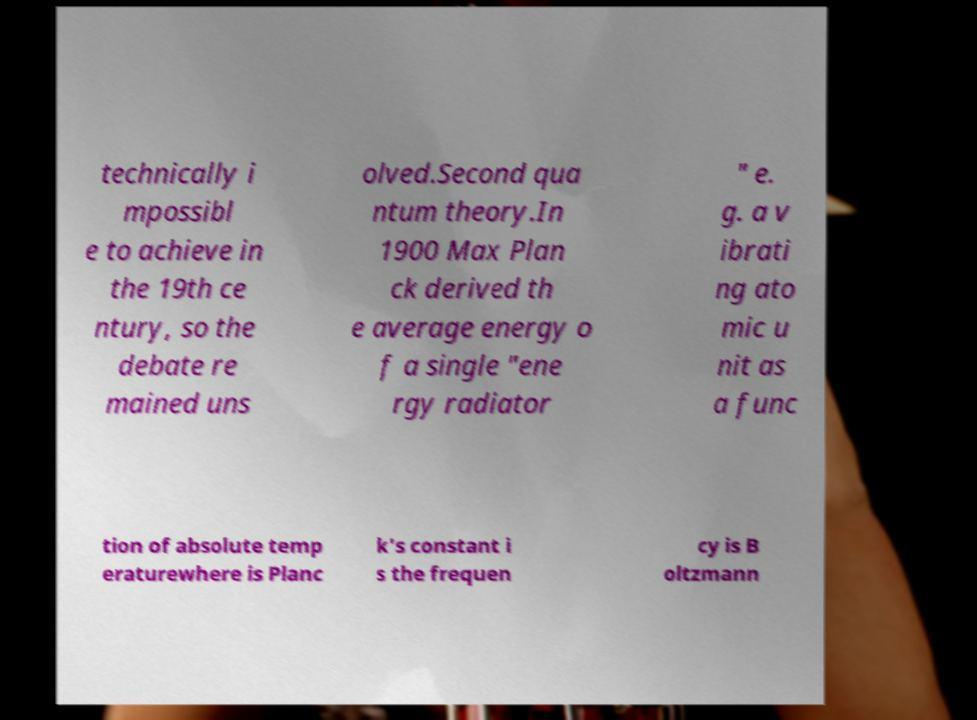I need the written content from this picture converted into text. Can you do that? technically i mpossibl e to achieve in the 19th ce ntury, so the debate re mained uns olved.Second qua ntum theory.In 1900 Max Plan ck derived th e average energy o f a single "ene rgy radiator " e. g. a v ibrati ng ato mic u nit as a func tion of absolute temp eraturewhere is Planc k's constant i s the frequen cy is B oltzmann 